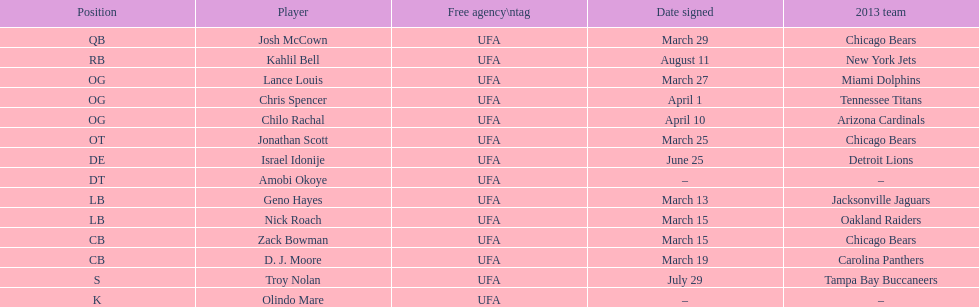How many players were signed in march? 7. 